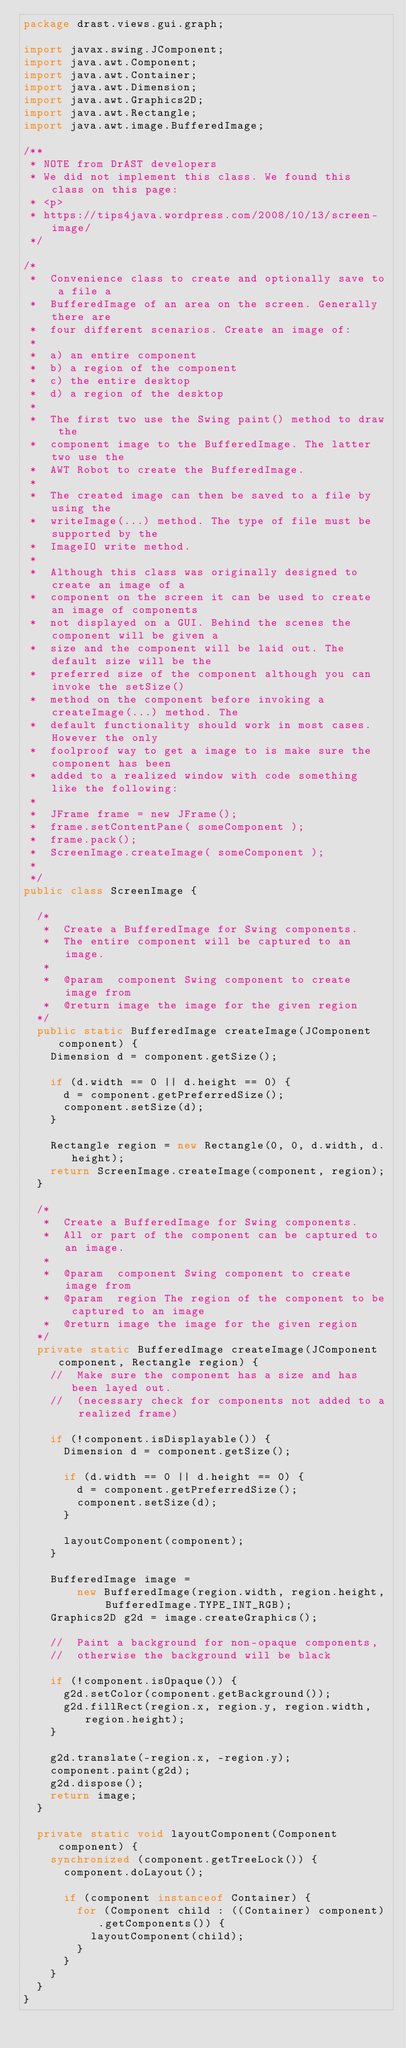Convert code to text. <code><loc_0><loc_0><loc_500><loc_500><_Java_>package drast.views.gui.graph;

import javax.swing.JComponent;
import java.awt.Component;
import java.awt.Container;
import java.awt.Dimension;
import java.awt.Graphics2D;
import java.awt.Rectangle;
import java.awt.image.BufferedImage;

/**
 * NOTE from DrAST developers
 * We did not implement this class. We found this class on this page:
 * <p>
 * https://tips4java.wordpress.com/2008/10/13/screen-image/
 */

/*
 *  Convenience class to create and optionally save to a file a
 *  BufferedImage of an area on the screen. Generally there are
 *  four different scenarios. Create an image of:
 *
 *  a) an entire component
 *  b) a region of the component
 *  c) the entire desktop
 *  d) a region of the desktop
 *
 *  The first two use the Swing paint() method to draw the
 *  component image to the BufferedImage. The latter two use the
 *  AWT Robot to create the BufferedImage.
 *
 *	The created image can then be saved to a file by using the
 *  writeImage(...) method. The type of file must be supported by the
 *  ImageIO write method.
 *
 *  Although this class was originally designed to create an image of a
 *  component on the screen it can be used to create an image of components
 *  not displayed on a GUI. Behind the scenes the component will be given a
 *  size and the component will be laid out. The default size will be the
 *  preferred size of the component although you can invoke the setSize()
 *  method on the component before invoking a createImage(...) method. The
 *  default functionality should work in most cases. However the only
 *  foolproof way to get a image to is make sure the component has been
 *  added to a realized window with code something like the following:
 *
 *  JFrame frame = new JFrame();
 *  frame.setContentPane( someComponent );
 *  frame.pack();
 *  ScreenImage.createImage( someComponent );
 *
 */
public class ScreenImage {

  /*
   *  Create a BufferedImage for Swing components.
   *  The entire component will be captured to an image.
   *
   *  @param  component Swing component to create image from
   *  @return	image the image for the given region
  */
  public static BufferedImage createImage(JComponent component) {
    Dimension d = component.getSize();

    if (d.width == 0 || d.height == 0) {
      d = component.getPreferredSize();
      component.setSize(d);
    }

    Rectangle region = new Rectangle(0, 0, d.width, d.height);
    return ScreenImage.createImage(component, region);
  }

  /*
   *  Create a BufferedImage for Swing components.
   *  All or part of the component can be captured to an image.
   *
   *  @param  component Swing component to create image from
   *  @param  region The region of the component to be captured to an image
   *  @return	image the image for the given region
  */
  private static BufferedImage createImage(JComponent component, Rectangle region) {
    //  Make sure the component has a size and has been layed out.
    //  (necessary check for components not added to a realized frame)

    if (!component.isDisplayable()) {
      Dimension d = component.getSize();

      if (d.width == 0 || d.height == 0) {
        d = component.getPreferredSize();
        component.setSize(d);
      }

      layoutComponent(component);
    }

    BufferedImage image =
        new BufferedImage(region.width, region.height, BufferedImage.TYPE_INT_RGB);
    Graphics2D g2d = image.createGraphics();

    //  Paint a background for non-opaque components,
    //  otherwise the background will be black

    if (!component.isOpaque()) {
      g2d.setColor(component.getBackground());
      g2d.fillRect(region.x, region.y, region.width, region.height);
    }

    g2d.translate(-region.x, -region.y);
    component.paint(g2d);
    g2d.dispose();
    return image;
  }

  private static void layoutComponent(Component component) {
    synchronized (component.getTreeLock()) {
      component.doLayout();

      if (component instanceof Container) {
        for (Component child : ((Container) component).getComponents()) {
          layoutComponent(child);
        }
      }
    }
  }
}
</code> 